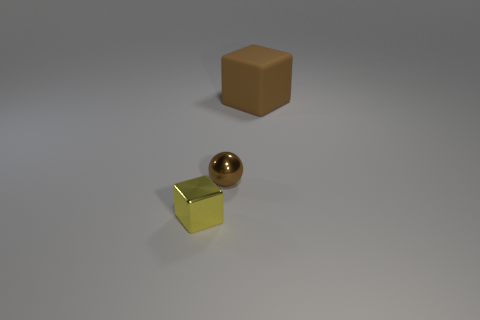How many other objects are there of the same color as the big rubber object?
Offer a terse response. 1. Does the large rubber block have the same color as the ball?
Your response must be concise. Yes. How many other objects are the same material as the small yellow cube?
Give a very brief answer. 1. There is a cube right of the tiny object that is in front of the tiny brown metallic sphere; how many small yellow objects are right of it?
Your response must be concise. 0. What number of rubber objects are tiny cubes or big cyan cylinders?
Ensure brevity in your answer.  0. What size is the metal object behind the shiny object to the left of the sphere?
Your response must be concise. Small. Do the thing that is behind the brown metallic ball and the small metal thing that is behind the tiny yellow metallic cube have the same color?
Offer a terse response. Yes. The object that is behind the small block and left of the large matte cube is what color?
Your response must be concise. Brown. Are the small brown sphere and the yellow cube made of the same material?
Ensure brevity in your answer.  Yes. What number of big objects are brown blocks or spheres?
Ensure brevity in your answer.  1. 